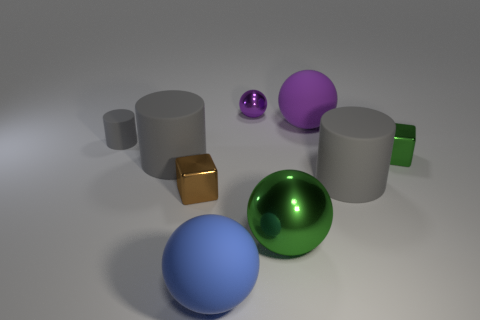Are there any brown things that have the same size as the green metal sphere?
Your answer should be compact. No. How many metallic objects are either small blue things or green things?
Your response must be concise. 2. The other object that is the same color as the large shiny object is what shape?
Provide a short and direct response. Cube. What number of large blue balls are there?
Make the answer very short. 1. Are the gray cylinder on the right side of the green ball and the tiny block that is to the right of the purple shiny thing made of the same material?
Your answer should be very brief. No. The green ball that is made of the same material as the small brown cube is what size?
Make the answer very short. Large. There is a gray rubber object that is right of the small brown metal cube; what shape is it?
Give a very brief answer. Cylinder. Do the matte cylinder to the right of the big green sphere and the tiny metal block right of the brown metal cube have the same color?
Provide a short and direct response. No. There is a metallic cube that is the same color as the large shiny object; what size is it?
Provide a succinct answer. Small. Are any yellow matte cylinders visible?
Offer a very short reply. No. 